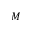Convert formula to latex. <formula><loc_0><loc_0><loc_500><loc_500>M</formula> 